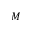Convert formula to latex. <formula><loc_0><loc_0><loc_500><loc_500>M</formula> 